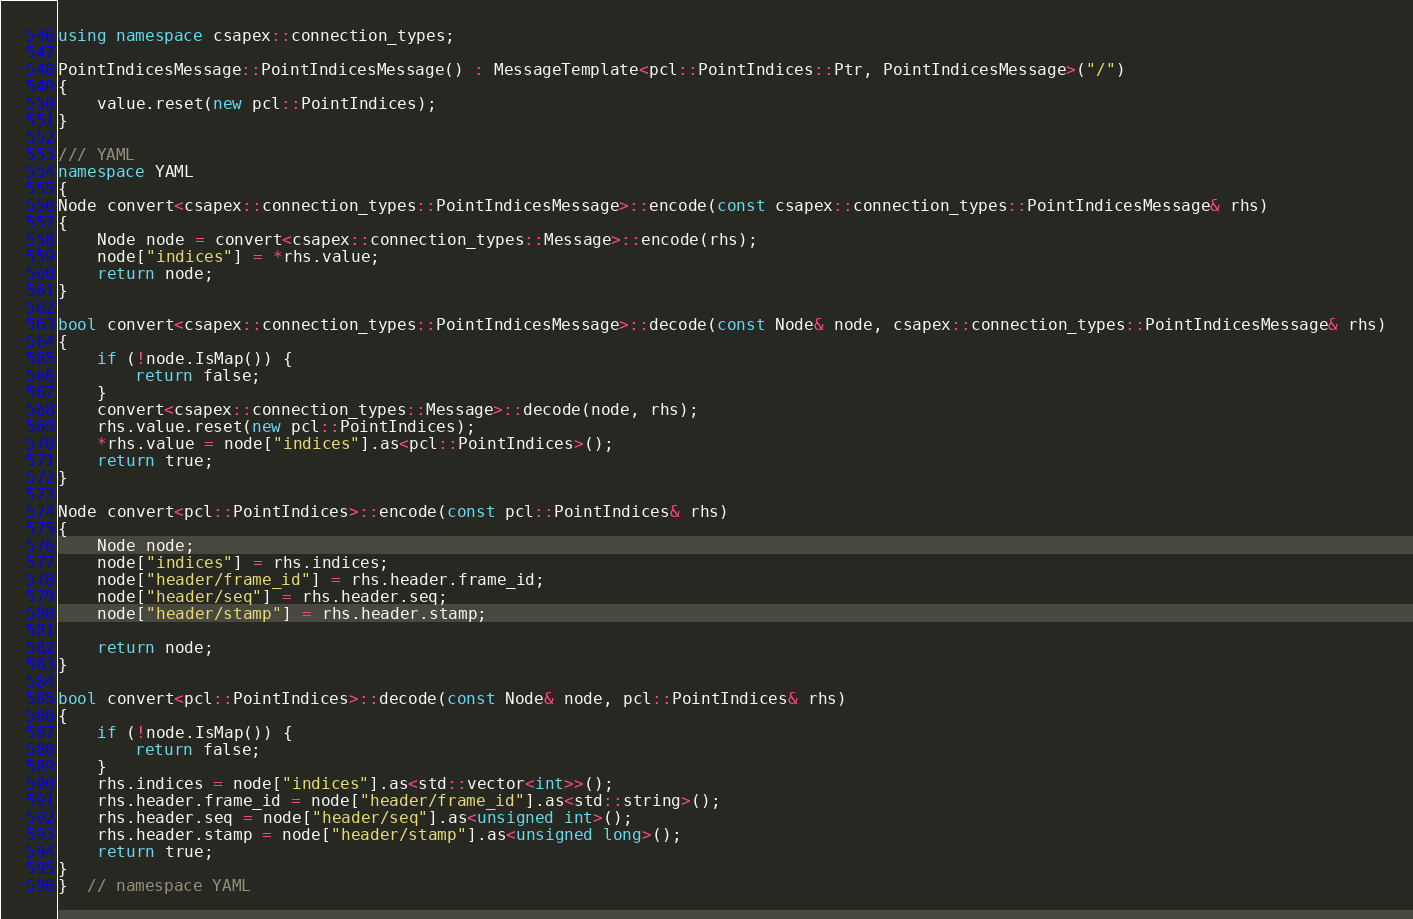Convert code to text. <code><loc_0><loc_0><loc_500><loc_500><_C++_>using namespace csapex::connection_types;

PointIndicesMessage::PointIndicesMessage() : MessageTemplate<pcl::PointIndices::Ptr, PointIndicesMessage>("/")
{
    value.reset(new pcl::PointIndices);
}

/// YAML
namespace YAML
{
Node convert<csapex::connection_types::PointIndicesMessage>::encode(const csapex::connection_types::PointIndicesMessage& rhs)
{
    Node node = convert<csapex::connection_types::Message>::encode(rhs);
    node["indices"] = *rhs.value;
    return node;
}

bool convert<csapex::connection_types::PointIndicesMessage>::decode(const Node& node, csapex::connection_types::PointIndicesMessage& rhs)
{
    if (!node.IsMap()) {
        return false;
    }
    convert<csapex::connection_types::Message>::decode(node, rhs);
    rhs.value.reset(new pcl::PointIndices);
    *rhs.value = node["indices"].as<pcl::PointIndices>();
    return true;
}

Node convert<pcl::PointIndices>::encode(const pcl::PointIndices& rhs)
{
    Node node;
    node["indices"] = rhs.indices;
    node["header/frame_id"] = rhs.header.frame_id;
    node["header/seq"] = rhs.header.seq;
    node["header/stamp"] = rhs.header.stamp;

    return node;
}

bool convert<pcl::PointIndices>::decode(const Node& node, pcl::PointIndices& rhs)
{
    if (!node.IsMap()) {
        return false;
    }
    rhs.indices = node["indices"].as<std::vector<int>>();
    rhs.header.frame_id = node["header/frame_id"].as<std::string>();
    rhs.header.seq = node["header/seq"].as<unsigned int>();
    rhs.header.stamp = node["header/stamp"].as<unsigned long>();
    return true;
}
}  // namespace YAML
</code> 